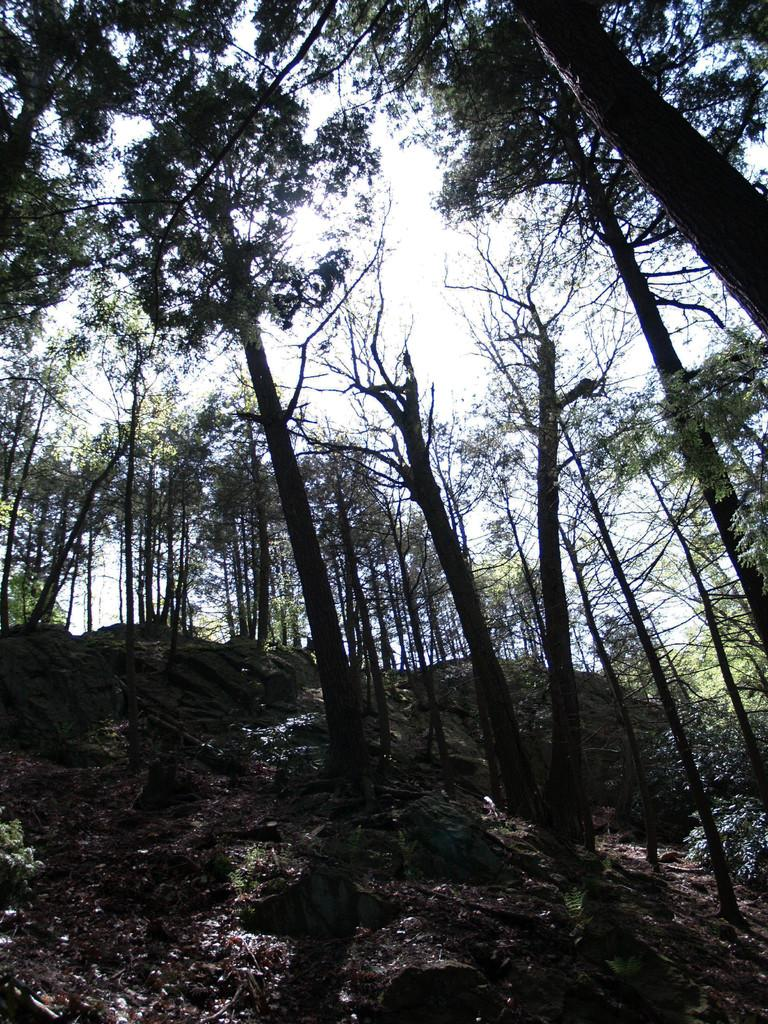What is visible on the ground in the image? The ground is visible in the image. What type of natural features can be seen on the ground? There are rocks in the image. What other natural elements are present in the image? There are trees in the image. What can be seen in the background of the image? The sky is visible in the background of the image. What type of bell can be heard ringing in the image? There is no bell present in the image, and therefore no sound can be heard. 